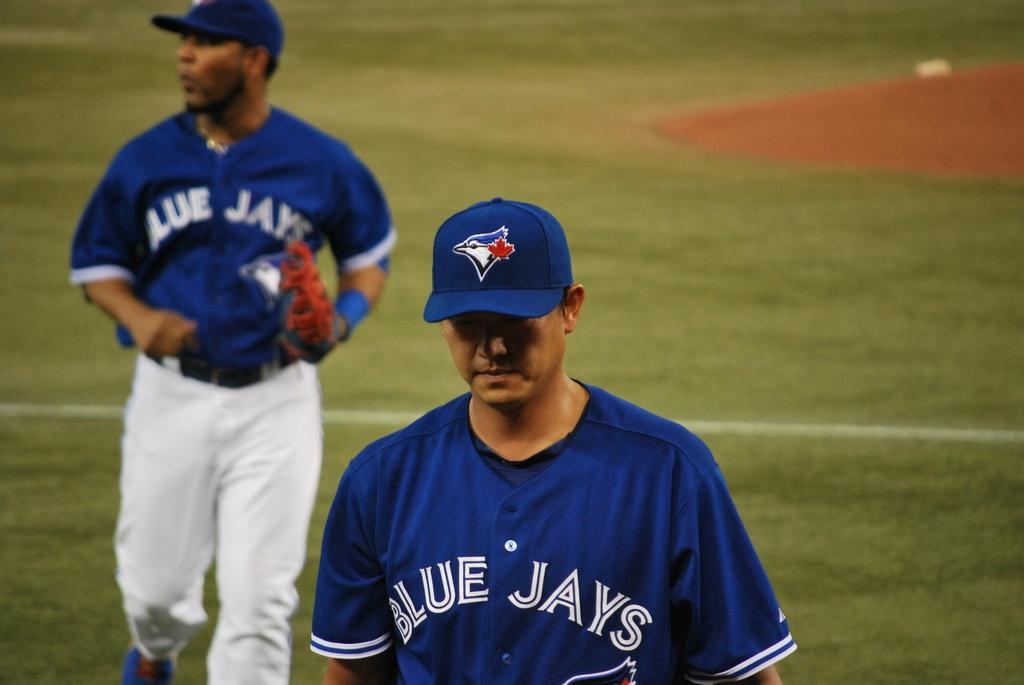Provide a one-sentence caption for the provided image. Two Blue Jays players are on the baseball field during a game. 